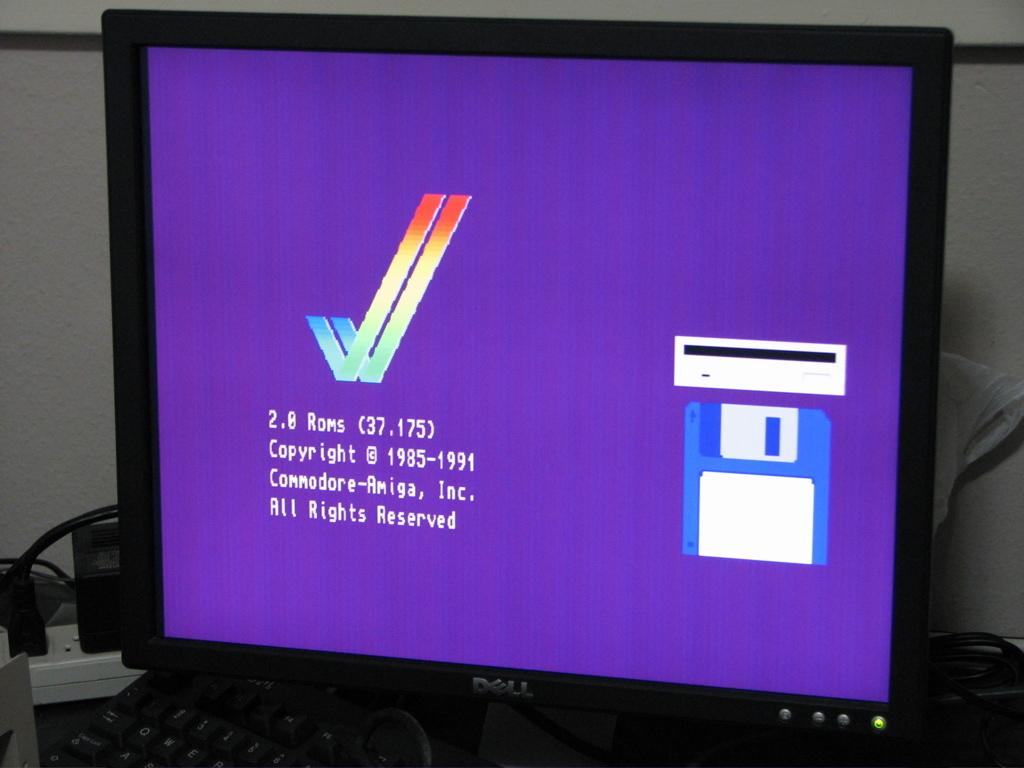What's the copyright years?
Provide a short and direct response. 1985-1991. What rights are reserved?
Keep it short and to the point. All rights. 